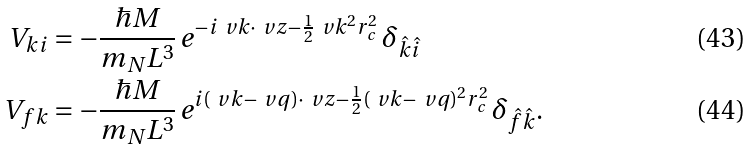Convert formula to latex. <formula><loc_0><loc_0><loc_500><loc_500>\ V _ { k i } & = - \frac { \hbar { M } } { m _ { N } L ^ { 3 } } \, e ^ { - i \ v k \cdot \ v z - \frac { 1 } { 2 } \ v k ^ { 2 } r _ { c } ^ { 2 } } \, \delta _ { \hat { k } \hat { i } } \\ \ V _ { f k } & = - \frac { \hbar { M } } { m _ { N } L ^ { 3 } } \, e ^ { i ( \ v k - \ v q ) \cdot \ v z - \frac { 1 } { 2 } ( \ v k - \ v q ) ^ { 2 } r _ { c } ^ { 2 } } \, \delta _ { \hat { f } \hat { k } } .</formula> 